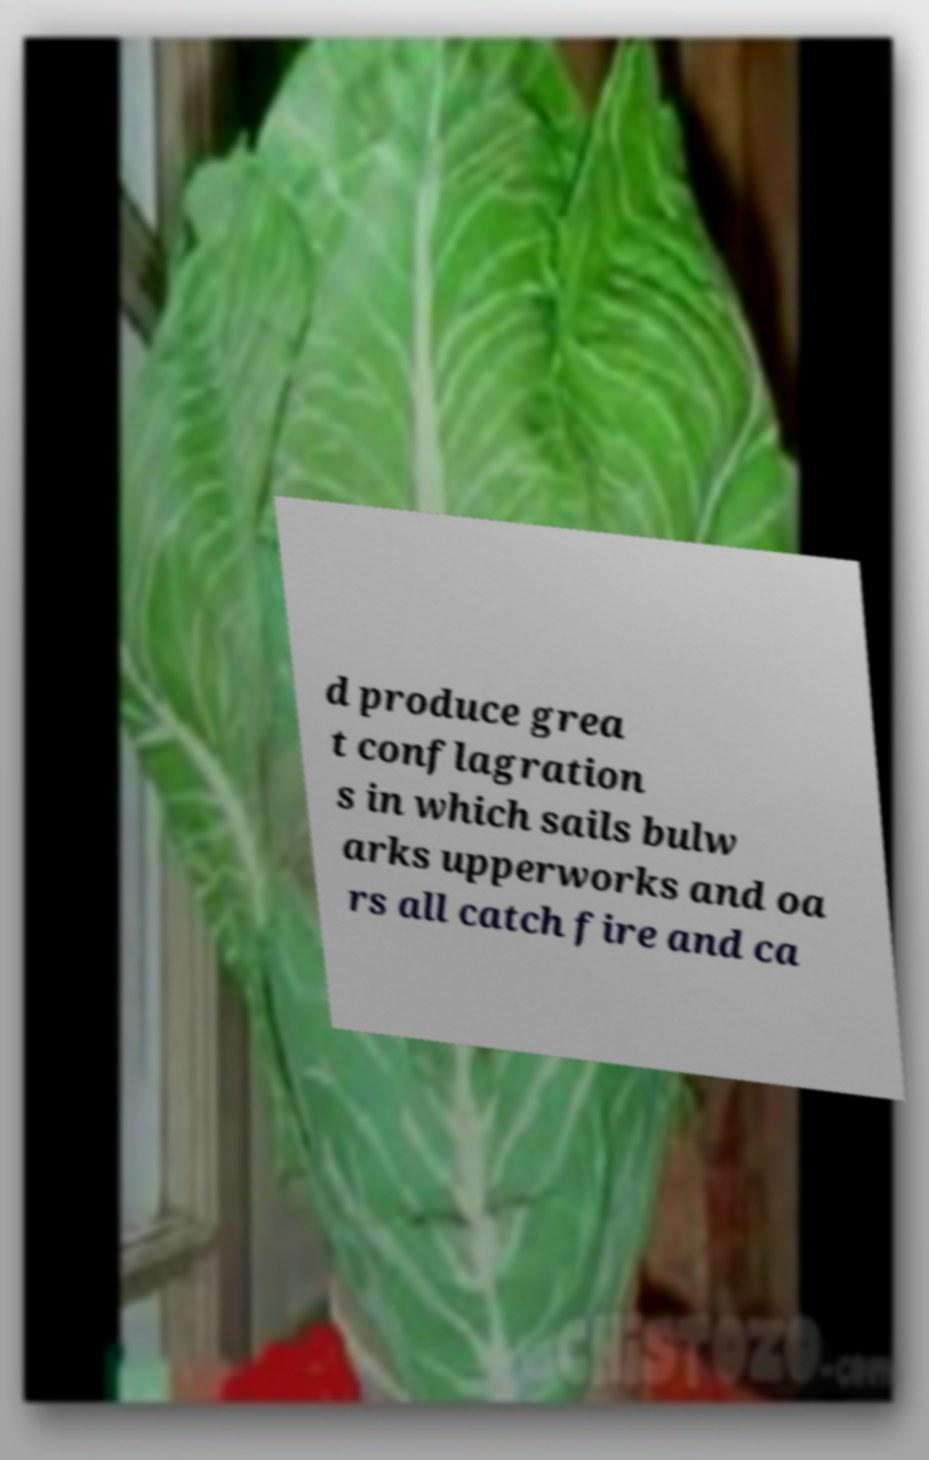I need the written content from this picture converted into text. Can you do that? d produce grea t conflagration s in which sails bulw arks upperworks and oa rs all catch fire and ca 